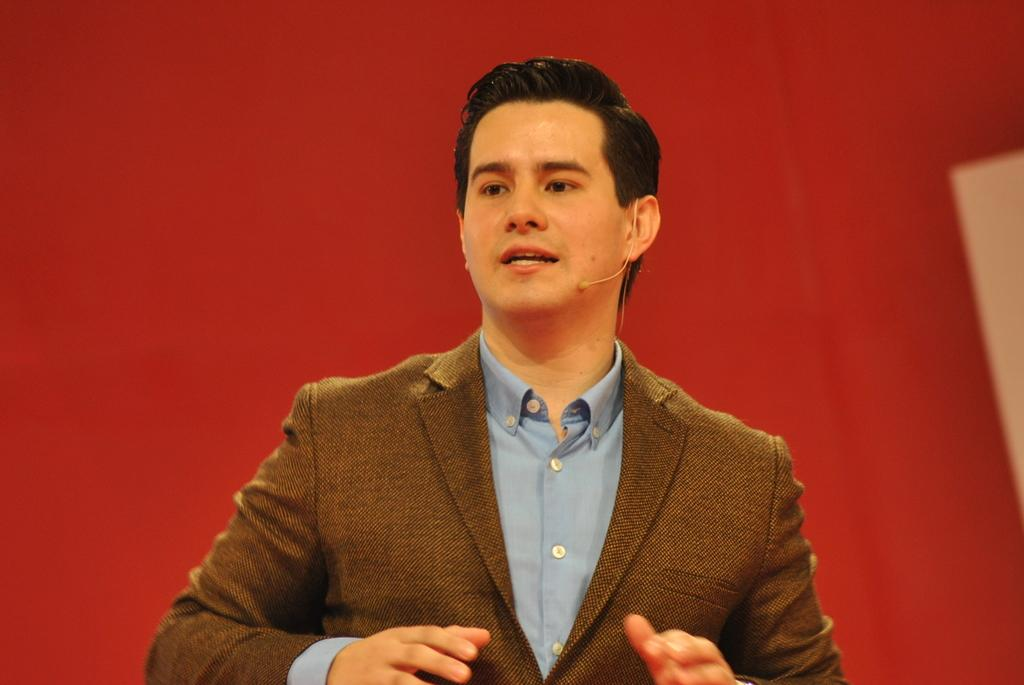What is the main subject of the image? There is a man in the image. What is the man doing in the image? The man is talking. What color is the background of the image? The background of the image is red. What type of wool can be seen in the image? There is no wool present in the image. Are there any cobwebs visible in the image? There are no cobwebs present in the image. 